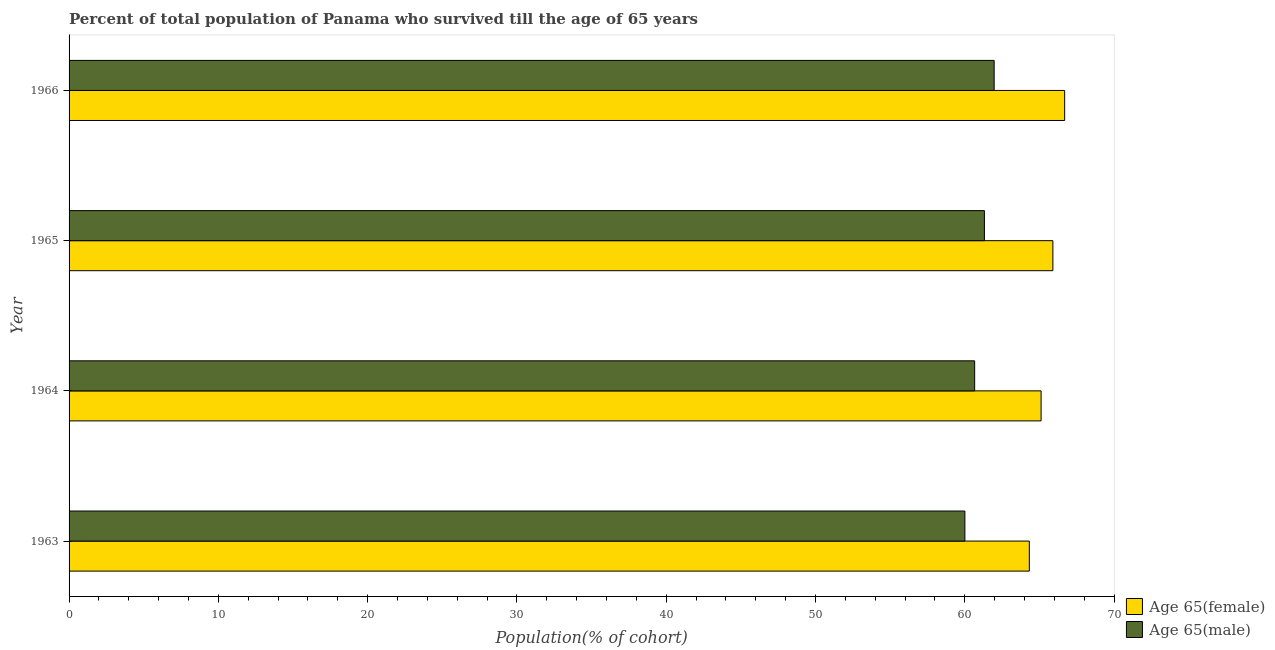How many different coloured bars are there?
Your answer should be very brief. 2. Are the number of bars per tick equal to the number of legend labels?
Keep it short and to the point. Yes. Are the number of bars on each tick of the Y-axis equal?
Provide a short and direct response. Yes. How many bars are there on the 1st tick from the top?
Ensure brevity in your answer.  2. How many bars are there on the 1st tick from the bottom?
Give a very brief answer. 2. What is the percentage of female population who survived till age of 65 in 1965?
Your answer should be very brief. 65.9. Across all years, what is the maximum percentage of male population who survived till age of 65?
Provide a short and direct response. 61.97. Across all years, what is the minimum percentage of female population who survived till age of 65?
Your answer should be very brief. 64.32. In which year was the percentage of male population who survived till age of 65 maximum?
Ensure brevity in your answer.  1966. What is the total percentage of male population who survived till age of 65 in the graph?
Provide a succinct answer. 243.95. What is the difference between the percentage of male population who survived till age of 65 in 1965 and that in 1966?
Your answer should be very brief. -0.65. What is the difference between the percentage of male population who survived till age of 65 in 1964 and the percentage of female population who survived till age of 65 in 1965?
Provide a short and direct response. -5.24. What is the average percentage of male population who survived till age of 65 per year?
Offer a terse response. 60.99. In the year 1963, what is the difference between the percentage of female population who survived till age of 65 and percentage of male population who survived till age of 65?
Your response must be concise. 4.32. What is the ratio of the percentage of male population who survived till age of 65 in 1964 to that in 1965?
Keep it short and to the point. 0.99. Is the percentage of female population who survived till age of 65 in 1964 less than that in 1965?
Provide a succinct answer. Yes. What is the difference between the highest and the second highest percentage of female population who survived till age of 65?
Ensure brevity in your answer.  0.79. What is the difference between the highest and the lowest percentage of male population who survived till age of 65?
Keep it short and to the point. 1.96. What does the 2nd bar from the top in 1963 represents?
Provide a short and direct response. Age 65(female). What does the 2nd bar from the bottom in 1964 represents?
Offer a terse response. Age 65(male). How many bars are there?
Give a very brief answer. 8. How many years are there in the graph?
Offer a very short reply. 4. What is the difference between two consecutive major ticks on the X-axis?
Your response must be concise. 10. Does the graph contain any zero values?
Offer a terse response. No. How are the legend labels stacked?
Ensure brevity in your answer.  Vertical. What is the title of the graph?
Your answer should be compact. Percent of total population of Panama who survived till the age of 65 years. Does "Nitrous oxide emissions" appear as one of the legend labels in the graph?
Offer a very short reply. No. What is the label or title of the X-axis?
Ensure brevity in your answer.  Population(% of cohort). What is the label or title of the Y-axis?
Provide a short and direct response. Year. What is the Population(% of cohort) in Age 65(female) in 1963?
Give a very brief answer. 64.32. What is the Population(% of cohort) of Age 65(male) in 1963?
Keep it short and to the point. 60.01. What is the Population(% of cohort) of Age 65(female) in 1964?
Provide a short and direct response. 65.11. What is the Population(% of cohort) of Age 65(male) in 1964?
Make the answer very short. 60.66. What is the Population(% of cohort) of Age 65(female) in 1965?
Your answer should be very brief. 65.9. What is the Population(% of cohort) of Age 65(male) in 1965?
Give a very brief answer. 61.31. What is the Population(% of cohort) of Age 65(female) in 1966?
Keep it short and to the point. 66.69. What is the Population(% of cohort) of Age 65(male) in 1966?
Ensure brevity in your answer.  61.97. Across all years, what is the maximum Population(% of cohort) in Age 65(female)?
Provide a succinct answer. 66.69. Across all years, what is the maximum Population(% of cohort) in Age 65(male)?
Keep it short and to the point. 61.97. Across all years, what is the minimum Population(% of cohort) of Age 65(female)?
Make the answer very short. 64.32. Across all years, what is the minimum Population(% of cohort) of Age 65(male)?
Your answer should be very brief. 60.01. What is the total Population(% of cohort) of Age 65(female) in the graph?
Make the answer very short. 262.02. What is the total Population(% of cohort) of Age 65(male) in the graph?
Offer a terse response. 243.95. What is the difference between the Population(% of cohort) in Age 65(female) in 1963 and that in 1964?
Make the answer very short. -0.79. What is the difference between the Population(% of cohort) of Age 65(male) in 1963 and that in 1964?
Offer a very short reply. -0.65. What is the difference between the Population(% of cohort) of Age 65(female) in 1963 and that in 1965?
Provide a short and direct response. -1.58. What is the difference between the Population(% of cohort) of Age 65(male) in 1963 and that in 1965?
Keep it short and to the point. -1.31. What is the difference between the Population(% of cohort) of Age 65(female) in 1963 and that in 1966?
Provide a short and direct response. -2.37. What is the difference between the Population(% of cohort) of Age 65(male) in 1963 and that in 1966?
Make the answer very short. -1.96. What is the difference between the Population(% of cohort) in Age 65(female) in 1964 and that in 1965?
Your response must be concise. -0.79. What is the difference between the Population(% of cohort) of Age 65(male) in 1964 and that in 1965?
Provide a short and direct response. -0.65. What is the difference between the Population(% of cohort) of Age 65(female) in 1964 and that in 1966?
Offer a terse response. -1.58. What is the difference between the Population(% of cohort) in Age 65(male) in 1964 and that in 1966?
Keep it short and to the point. -1.31. What is the difference between the Population(% of cohort) in Age 65(female) in 1965 and that in 1966?
Your answer should be compact. -0.79. What is the difference between the Population(% of cohort) in Age 65(male) in 1965 and that in 1966?
Give a very brief answer. -0.65. What is the difference between the Population(% of cohort) of Age 65(female) in 1963 and the Population(% of cohort) of Age 65(male) in 1964?
Ensure brevity in your answer.  3.66. What is the difference between the Population(% of cohort) in Age 65(female) in 1963 and the Population(% of cohort) in Age 65(male) in 1965?
Your answer should be very brief. 3.01. What is the difference between the Population(% of cohort) in Age 65(female) in 1963 and the Population(% of cohort) in Age 65(male) in 1966?
Provide a short and direct response. 2.36. What is the difference between the Population(% of cohort) of Age 65(female) in 1964 and the Population(% of cohort) of Age 65(male) in 1965?
Your answer should be very brief. 3.8. What is the difference between the Population(% of cohort) in Age 65(female) in 1964 and the Population(% of cohort) in Age 65(male) in 1966?
Keep it short and to the point. 3.14. What is the difference between the Population(% of cohort) of Age 65(female) in 1965 and the Population(% of cohort) of Age 65(male) in 1966?
Make the answer very short. 3.93. What is the average Population(% of cohort) in Age 65(female) per year?
Provide a short and direct response. 65.51. What is the average Population(% of cohort) in Age 65(male) per year?
Make the answer very short. 60.99. In the year 1963, what is the difference between the Population(% of cohort) in Age 65(female) and Population(% of cohort) in Age 65(male)?
Provide a succinct answer. 4.32. In the year 1964, what is the difference between the Population(% of cohort) in Age 65(female) and Population(% of cohort) in Age 65(male)?
Your answer should be compact. 4.45. In the year 1965, what is the difference between the Population(% of cohort) in Age 65(female) and Population(% of cohort) in Age 65(male)?
Give a very brief answer. 4.59. In the year 1966, what is the difference between the Population(% of cohort) in Age 65(female) and Population(% of cohort) in Age 65(male)?
Keep it short and to the point. 4.72. What is the ratio of the Population(% of cohort) in Age 65(female) in 1963 to that in 1964?
Your answer should be very brief. 0.99. What is the ratio of the Population(% of cohort) in Age 65(male) in 1963 to that in 1964?
Your answer should be compact. 0.99. What is the ratio of the Population(% of cohort) of Age 65(female) in 1963 to that in 1965?
Offer a terse response. 0.98. What is the ratio of the Population(% of cohort) in Age 65(male) in 1963 to that in 1965?
Offer a very short reply. 0.98. What is the ratio of the Population(% of cohort) of Age 65(female) in 1963 to that in 1966?
Make the answer very short. 0.96. What is the ratio of the Population(% of cohort) of Age 65(male) in 1963 to that in 1966?
Ensure brevity in your answer.  0.97. What is the ratio of the Population(% of cohort) in Age 65(female) in 1964 to that in 1965?
Provide a short and direct response. 0.99. What is the ratio of the Population(% of cohort) in Age 65(male) in 1964 to that in 1965?
Keep it short and to the point. 0.99. What is the ratio of the Population(% of cohort) of Age 65(female) in 1964 to that in 1966?
Offer a very short reply. 0.98. What is the ratio of the Population(% of cohort) of Age 65(male) in 1964 to that in 1966?
Provide a succinct answer. 0.98. What is the ratio of the Population(% of cohort) in Age 65(male) in 1965 to that in 1966?
Keep it short and to the point. 0.99. What is the difference between the highest and the second highest Population(% of cohort) in Age 65(female)?
Provide a succinct answer. 0.79. What is the difference between the highest and the second highest Population(% of cohort) in Age 65(male)?
Provide a succinct answer. 0.65. What is the difference between the highest and the lowest Population(% of cohort) in Age 65(female)?
Your response must be concise. 2.37. What is the difference between the highest and the lowest Population(% of cohort) of Age 65(male)?
Your response must be concise. 1.96. 